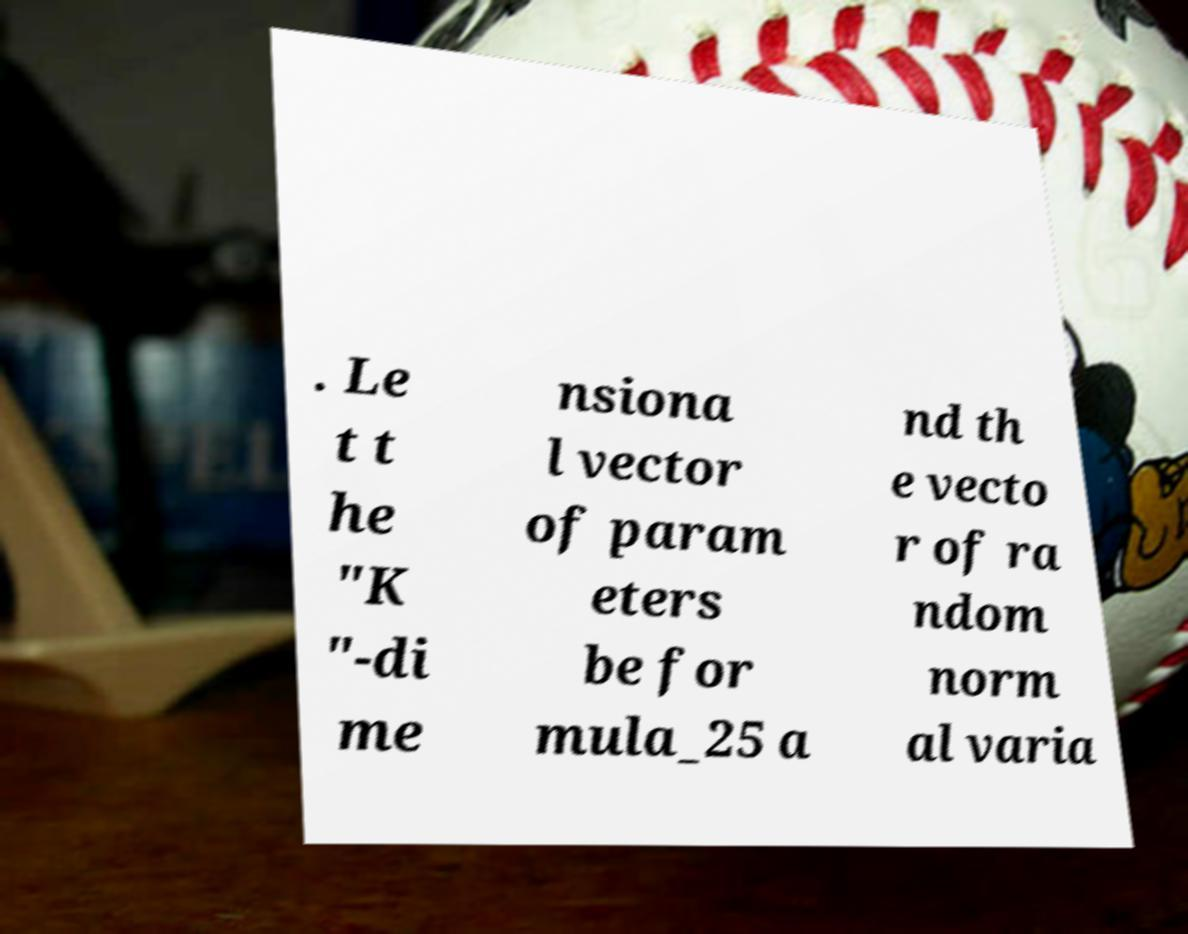I need the written content from this picture converted into text. Can you do that? . Le t t he "K "-di me nsiona l vector of param eters be for mula_25 a nd th e vecto r of ra ndom norm al varia 